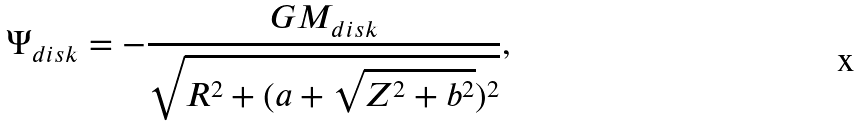Convert formula to latex. <formula><loc_0><loc_0><loc_500><loc_500>\Psi _ { d i s k } = - \frac { G M _ { d i s k } } { \sqrt { R ^ { 2 } + ( a + \sqrt { Z ^ { 2 } + b ^ { 2 } } ) ^ { 2 } } } ,</formula> 